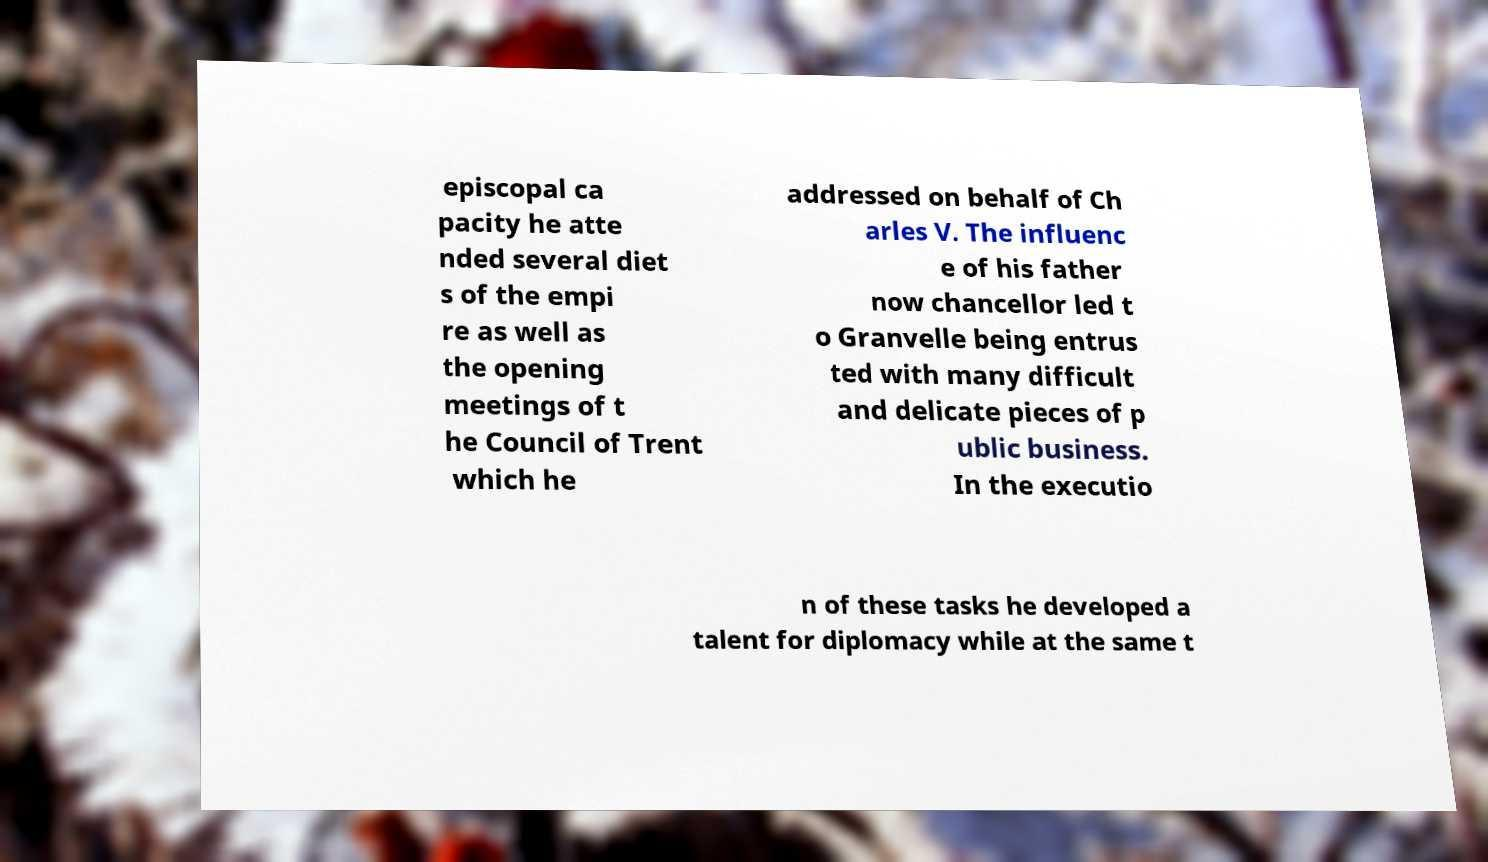Could you assist in decoding the text presented in this image and type it out clearly? episcopal ca pacity he atte nded several diet s of the empi re as well as the opening meetings of t he Council of Trent which he addressed on behalf of Ch arles V. The influenc e of his father now chancellor led t o Granvelle being entrus ted with many difficult and delicate pieces of p ublic business. In the executio n of these tasks he developed a talent for diplomacy while at the same t 